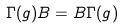<formula> <loc_0><loc_0><loc_500><loc_500>\Gamma ( g ) B = B \Gamma ( g )</formula> 